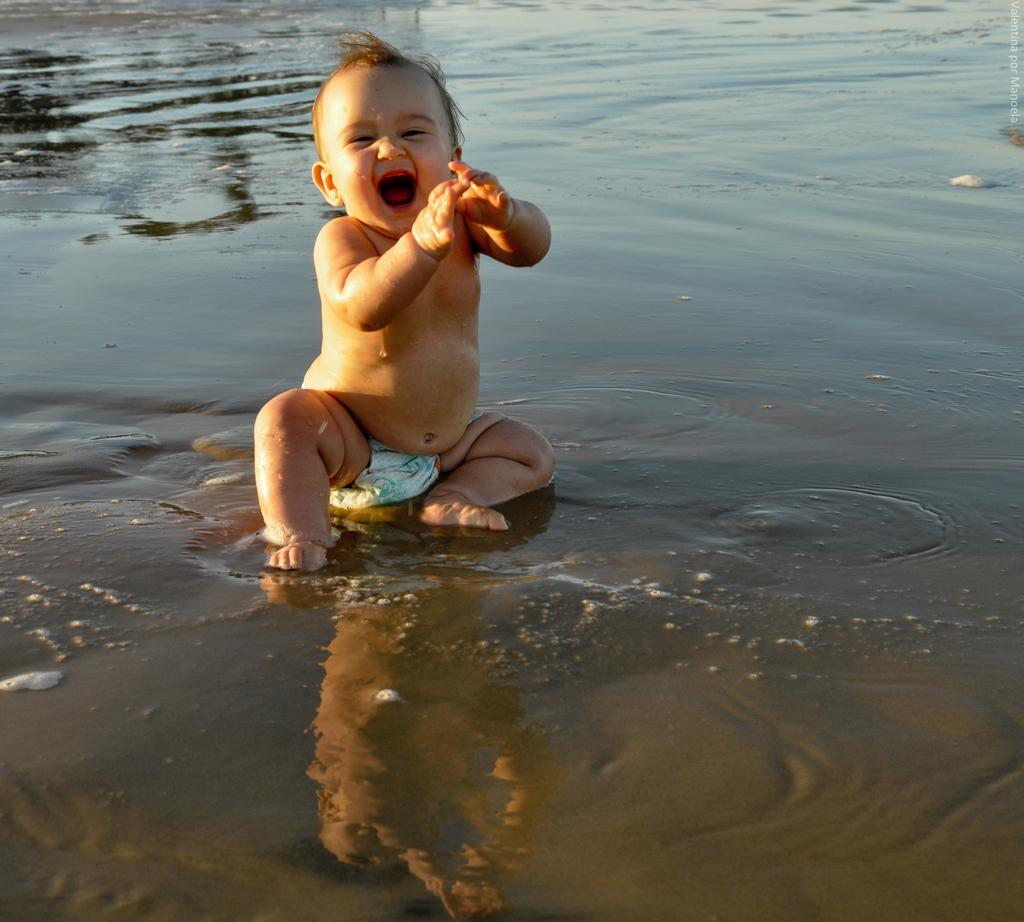Who is the main subject in the image? There is a kid in the image. What is the kid doing in the image? The kid is in the water. Where might the image have been taken? The image is likely taken near a lake. When was the image taken? The image was taken during the day. What type of prose can be heard in the background of the image? There is no prose or any sound present in the image, as it is a still photograph. Where is the faucet located in the image? There is no faucet present in the image. 